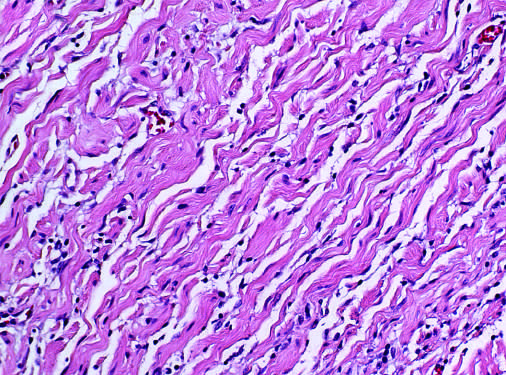re the portal tracts seen to consist of bland spindle cells admixed with wavy collagen bundles likened to carrot shavings?
Answer the question using a single word or phrase. No 